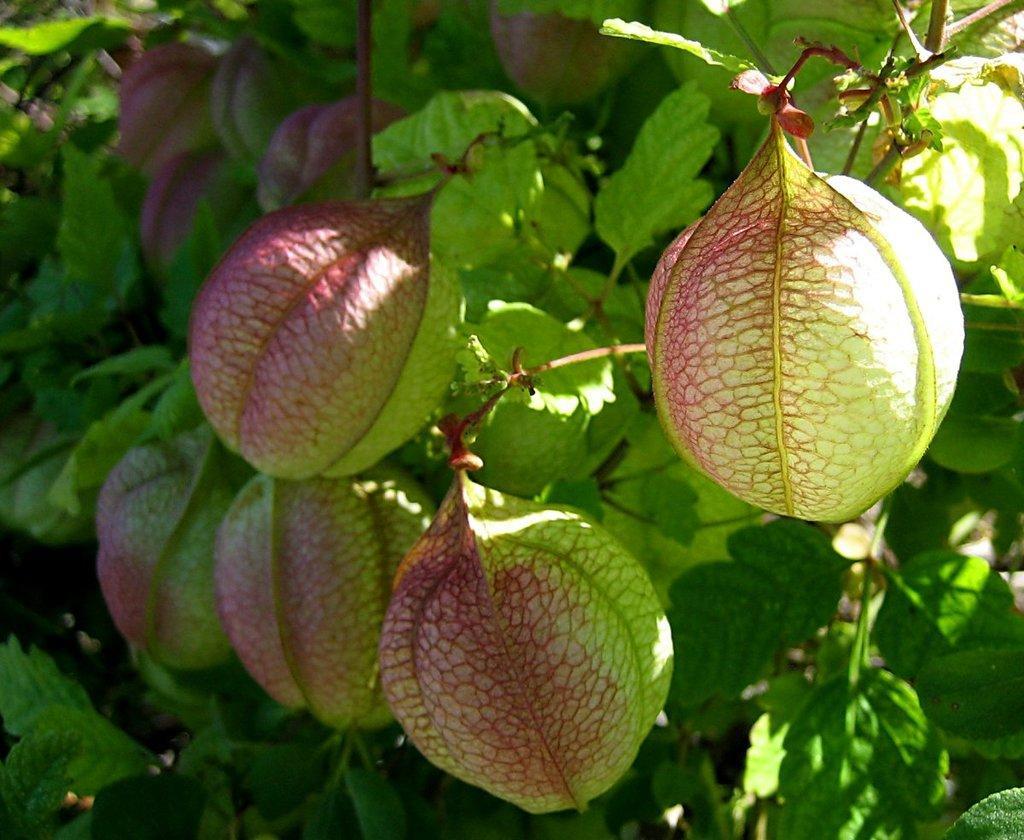Please provide a concise description of this image. In this picture we can see leaves and balloon vine. 